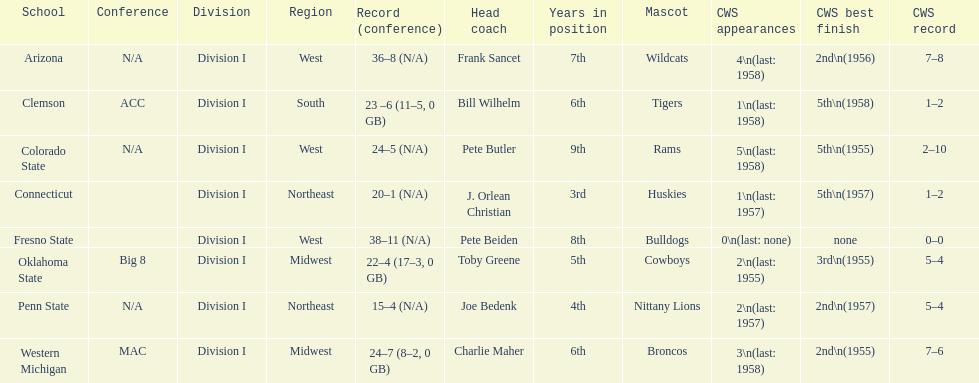Oklahoma state and penn state both have how many cws appearances? 2. 